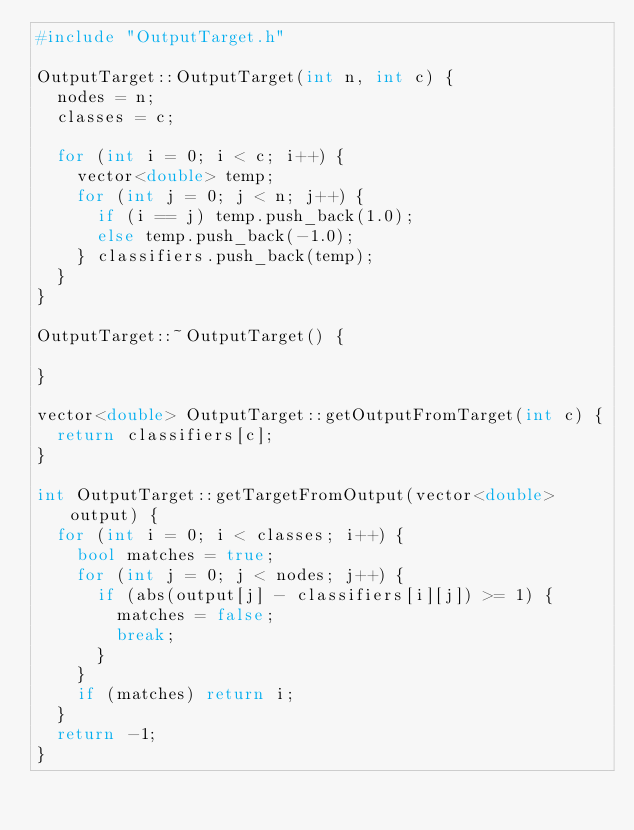Convert code to text. <code><loc_0><loc_0><loc_500><loc_500><_C++_>#include "OutputTarget.h"

OutputTarget::OutputTarget(int n, int c) {
	nodes = n;
	classes = c;

	for (int i = 0; i < c; i++) {
		vector<double> temp;
		for (int j = 0; j < n; j++) {
			if (i == j) temp.push_back(1.0);
			else temp.push_back(-1.0);
		} classifiers.push_back(temp);
	}
}

OutputTarget::~OutputTarget() {

}

vector<double> OutputTarget::getOutputFromTarget(int c) {
	return classifiers[c];
}

int OutputTarget::getTargetFromOutput(vector<double> output) {
	for (int i = 0; i < classes; i++) {
		bool matches = true;
		for (int j = 0; j < nodes; j++) {
			if (abs(output[j] - classifiers[i][j]) >= 1) {
				matches = false;
				break;
			}
		}
		if (matches) return i;
	}
	return -1;
}

</code> 